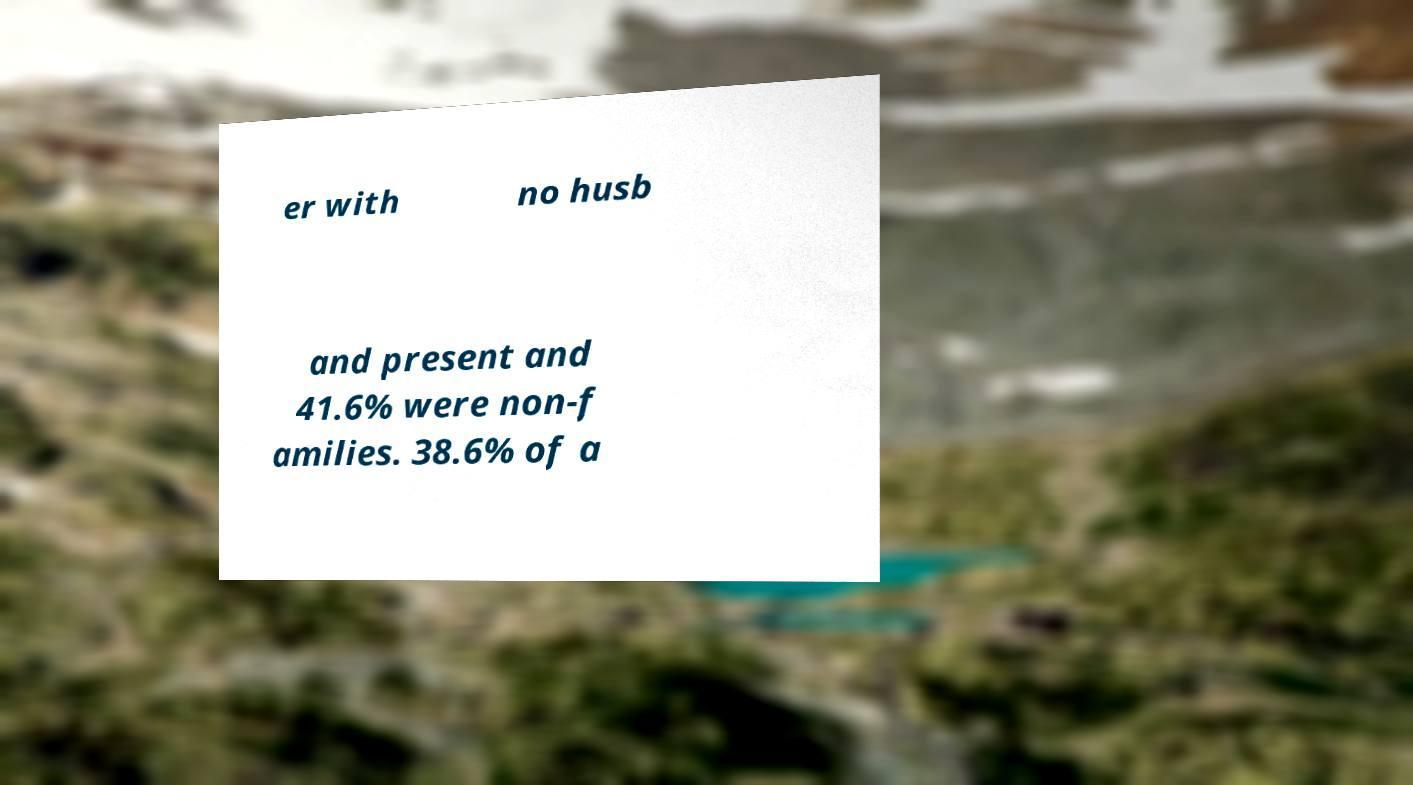Could you assist in decoding the text presented in this image and type it out clearly? er with no husb and present and 41.6% were non-f amilies. 38.6% of a 